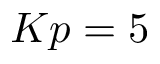Convert formula to latex. <formula><loc_0><loc_0><loc_500><loc_500>K p = 5</formula> 